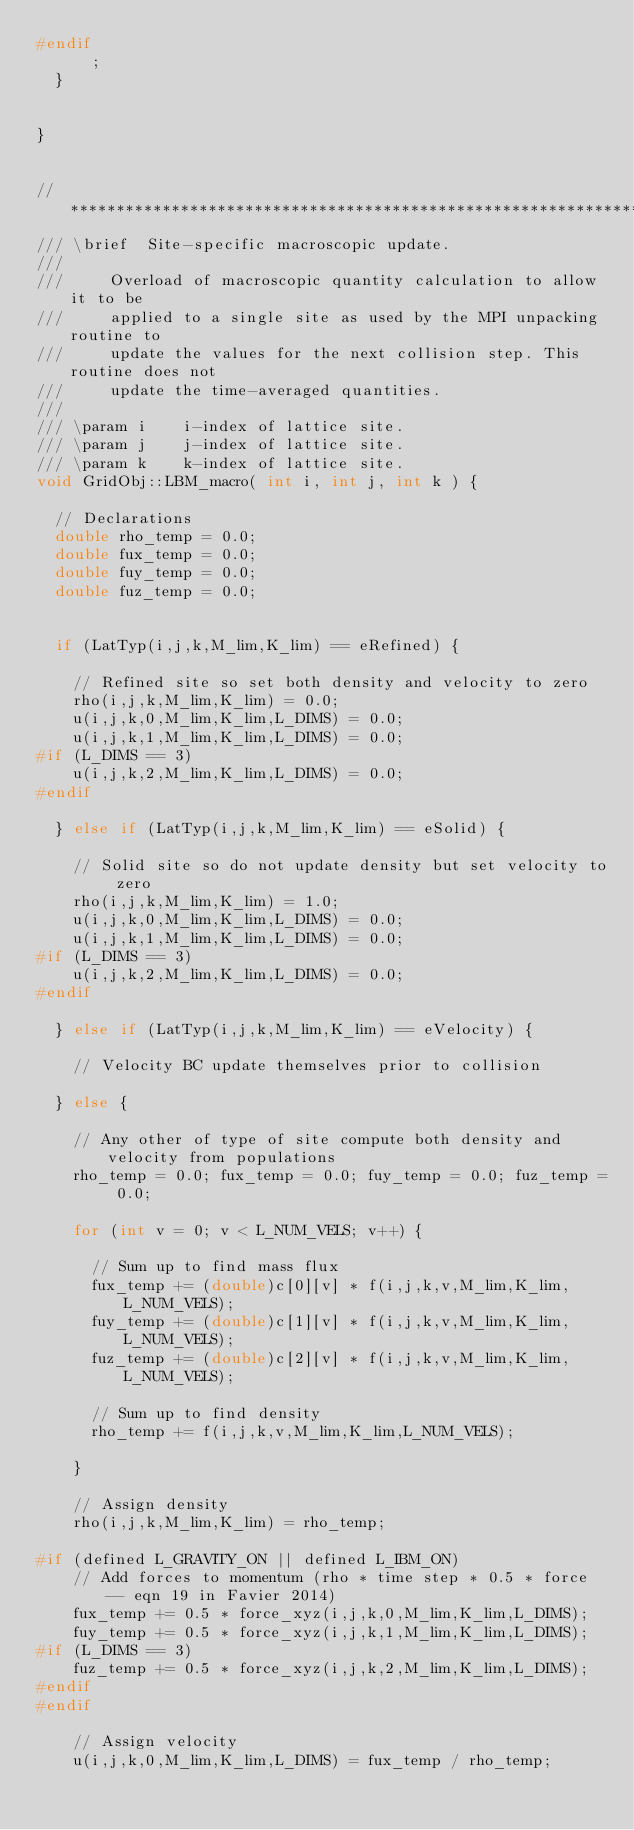<code> <loc_0><loc_0><loc_500><loc_500><_C++_>#endif
			;
	}


}


// *****************************************************************************
/// \brief	Site-specific macroscopic update.
///
///			Overload of macroscopic quantity calculation to allow it to be 
///			applied to a single site as used by the MPI unpacking routine to 
///			update the values for the next collision step. This routine does not
///			update the time-averaged quantities.
///
/// \param i		i-index of lattice site. 
/// \param j		j-index of lattice site.
/// \param k		k-index of lattice site.
void GridObj::LBM_macro( int i, int j, int k ) {

	// Declarations
	double rho_temp = 0.0;
	double fux_temp = 0.0;
	double fuy_temp = 0.0;
	double fuz_temp = 0.0;


	if (LatTyp(i,j,k,M_lim,K_lim) == eRefined) {

		// Refined site so set both density and velocity to zero
		rho(i,j,k,M_lim,K_lim) = 0.0;
		u(i,j,k,0,M_lim,K_lim,L_DIMS) = 0.0;
		u(i,j,k,1,M_lim,K_lim,L_DIMS) = 0.0;
#if (L_DIMS == 3)
		u(i,j,k,2,M_lim,K_lim,L_DIMS) = 0.0;
#endif

	} else if (LatTyp(i,j,k,M_lim,K_lim) == eSolid) {

		// Solid site so do not update density but set velocity to zero
		rho(i,j,k,M_lim,K_lim) = 1.0;
		u(i,j,k,0,M_lim,K_lim,L_DIMS) = 0.0;
		u(i,j,k,1,M_lim,K_lim,L_DIMS) = 0.0;
#if (L_DIMS == 3)
		u(i,j,k,2,M_lim,K_lim,L_DIMS) = 0.0;
#endif

	} else if (LatTyp(i,j,k,M_lim,K_lim) == eVelocity) {

		// Velocity BC update themselves prior to collision

	} else {

		// Any other of type of site compute both density and velocity from populations
		rho_temp = 0.0; fux_temp = 0.0; fuy_temp = 0.0; fuz_temp = 0.0;

		for (int v = 0; v < L_NUM_VELS; v++) {

			// Sum up to find mass flux
			fux_temp += (double)c[0][v] * f(i,j,k,v,M_lim,K_lim,L_NUM_VELS);
			fuy_temp += (double)c[1][v] * f(i,j,k,v,M_lim,K_lim,L_NUM_VELS);
			fuz_temp += (double)c[2][v] * f(i,j,k,v,M_lim,K_lim,L_NUM_VELS);

			// Sum up to find density
			rho_temp += f(i,j,k,v,M_lim,K_lim,L_NUM_VELS);

		}

		// Assign density
		rho(i,j,k,M_lim,K_lim) = rho_temp;

#if (defined L_GRAVITY_ON || defined L_IBM_ON)
		// Add forces to momentum (rho * time step * 0.5 * force -- eqn 19 in Favier 2014)
		fux_temp += 0.5 * force_xyz(i,j,k,0,M_lim,K_lim,L_DIMS);
		fuy_temp += 0.5 * force_xyz(i,j,k,1,M_lim,K_lim,L_DIMS);
#if (L_DIMS == 3)
		fuz_temp += 0.5 * force_xyz(i,j,k,2,M_lim,K_lim,L_DIMS);
#endif
#endif

		// Assign velocity
		u(i,j,k,0,M_lim,K_lim,L_DIMS) = fux_temp / rho_temp;</code> 